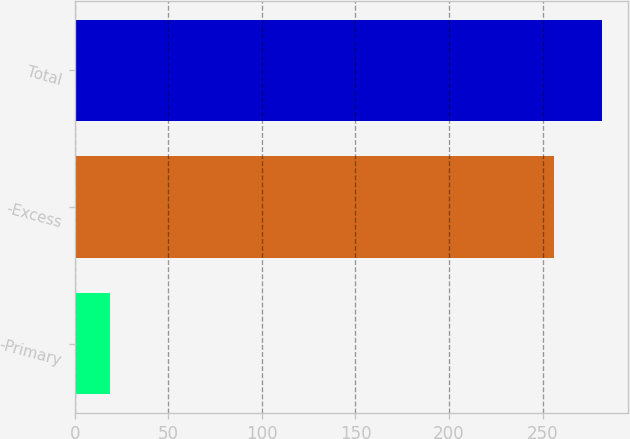<chart> <loc_0><loc_0><loc_500><loc_500><bar_chart><fcel>-Primary<fcel>-Excess<fcel>Total<nl><fcel>19<fcel>256<fcel>281.6<nl></chart> 